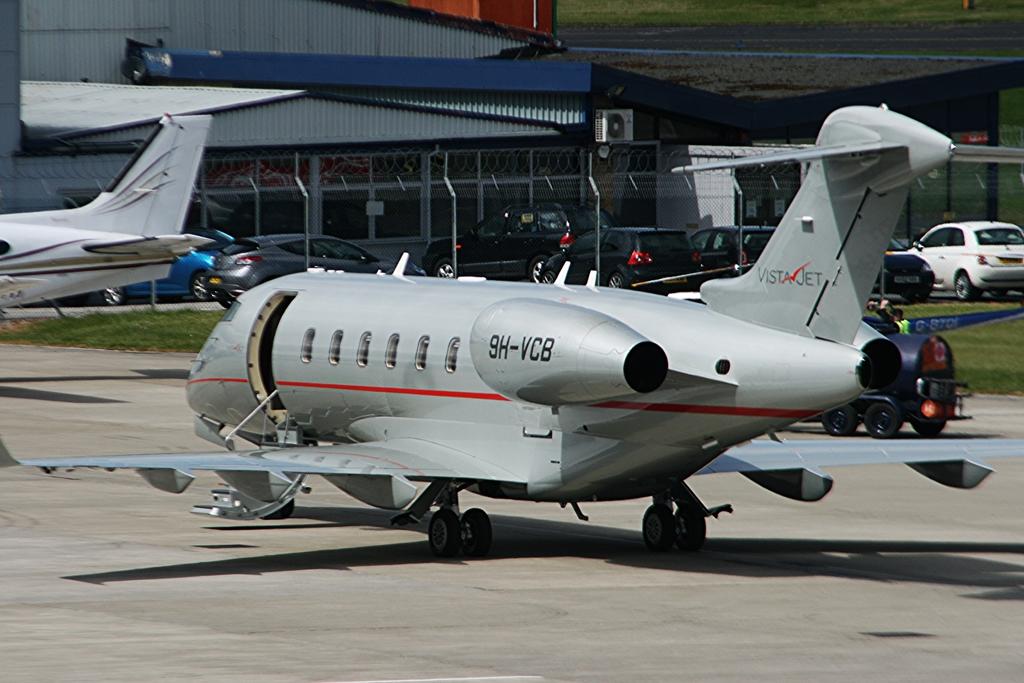What is the model plane number shown on the engine?
Your answer should be very brief. 9h-vcb. 